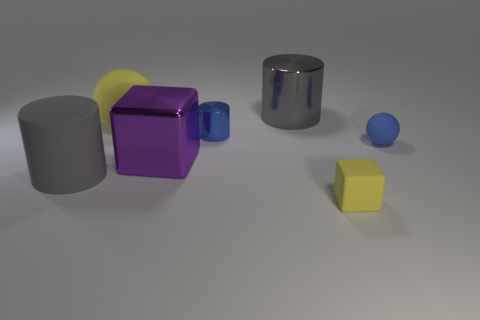How many things are either big gray things or large rubber things in front of the purple metal cube? After closely examining the image, it appears there is one large gray cylinder and one smaller round blue object that could be described as rubber due to its matte finish, both positioned in front of the purple metal cube. Therefore, there are two objects fitting the criteria provided. 